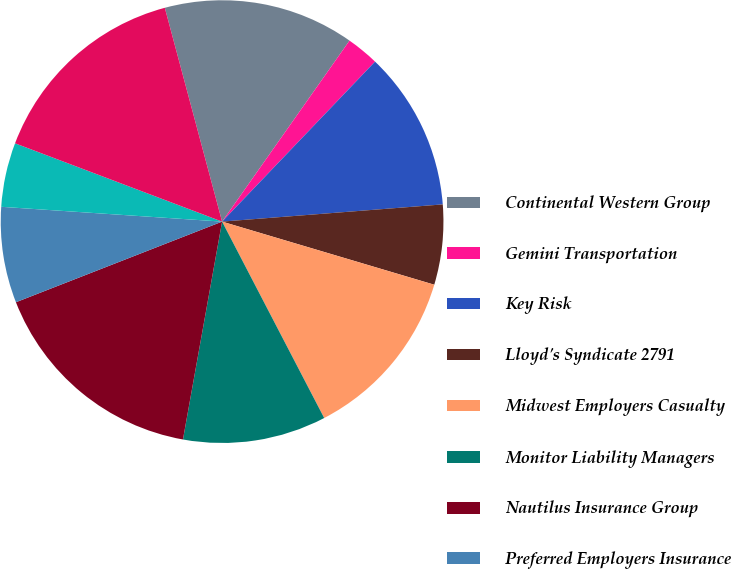Convert chart to OTSL. <chart><loc_0><loc_0><loc_500><loc_500><pie_chart><fcel>Continental Western Group<fcel>Gemini Transportation<fcel>Key Risk<fcel>Lloyd's Syndicate 2791<fcel>Midwest Employers Casualty<fcel>Monitor Liability Managers<fcel>Nautilus Insurance Group<fcel>Preferred Employers Insurance<fcel>Riverport Insurances Services<fcel>Union Standard<nl><fcel>13.93%<fcel>2.38%<fcel>11.62%<fcel>5.84%<fcel>12.77%<fcel>10.46%<fcel>16.24%<fcel>7.0%<fcel>4.69%<fcel>15.08%<nl></chart> 